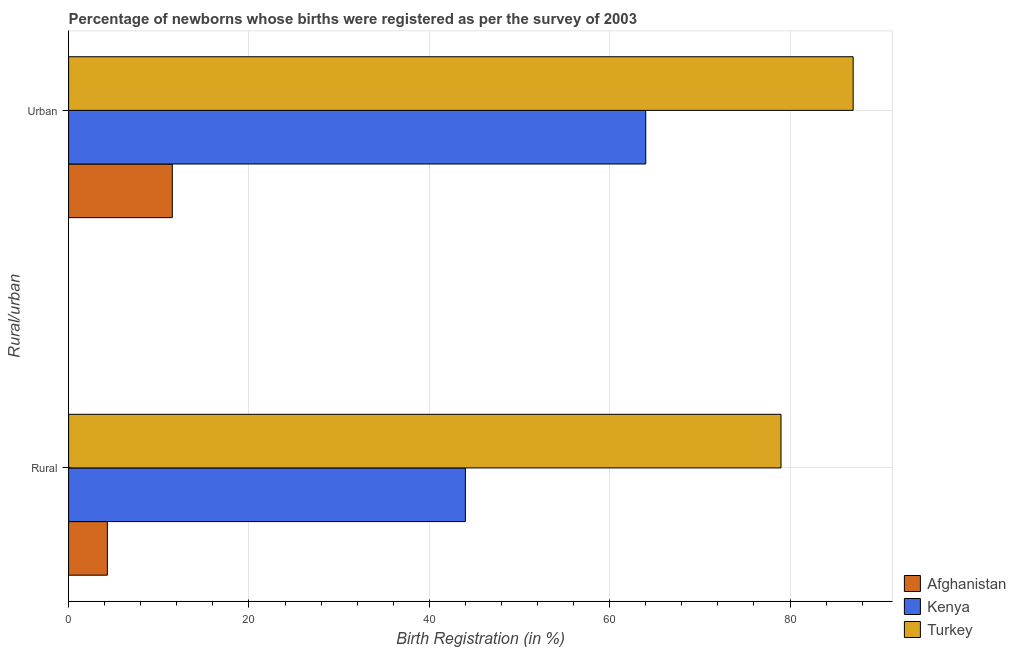Are the number of bars per tick equal to the number of legend labels?
Offer a terse response. Yes. Are the number of bars on each tick of the Y-axis equal?
Ensure brevity in your answer.  Yes. How many bars are there on the 1st tick from the top?
Your answer should be compact. 3. How many bars are there on the 2nd tick from the bottom?
Provide a succinct answer. 3. What is the label of the 1st group of bars from the top?
Your answer should be compact. Urban. What is the rural birth registration in Kenya?
Your answer should be compact. 44. Across all countries, what is the maximum rural birth registration?
Provide a succinct answer. 79. Across all countries, what is the minimum rural birth registration?
Provide a succinct answer. 4.3. In which country was the rural birth registration minimum?
Your answer should be very brief. Afghanistan. What is the total rural birth registration in the graph?
Your answer should be very brief. 127.3. What is the difference between the urban birth registration in Afghanistan and that in Turkey?
Make the answer very short. -75.5. What is the difference between the urban birth registration in Turkey and the rural birth registration in Afghanistan?
Give a very brief answer. 82.7. What is the average rural birth registration per country?
Give a very brief answer. 42.43. What is the difference between the urban birth registration and rural birth registration in Afghanistan?
Provide a short and direct response. 7.2. In how many countries, is the rural birth registration greater than 8 %?
Offer a terse response. 2. What is the ratio of the urban birth registration in Kenya to that in Afghanistan?
Provide a succinct answer. 5.57. What does the 2nd bar from the top in Urban represents?
Make the answer very short. Kenya. What does the 2nd bar from the bottom in Rural represents?
Provide a succinct answer. Kenya. Are the values on the major ticks of X-axis written in scientific E-notation?
Offer a terse response. No. How are the legend labels stacked?
Provide a succinct answer. Vertical. What is the title of the graph?
Provide a succinct answer. Percentage of newborns whose births were registered as per the survey of 2003. Does "Uruguay" appear as one of the legend labels in the graph?
Your answer should be very brief. No. What is the label or title of the X-axis?
Provide a succinct answer. Birth Registration (in %). What is the label or title of the Y-axis?
Offer a terse response. Rural/urban. What is the Birth Registration (in %) in Afghanistan in Rural?
Keep it short and to the point. 4.3. What is the Birth Registration (in %) in Kenya in Rural?
Offer a very short reply. 44. What is the Birth Registration (in %) of Turkey in Rural?
Keep it short and to the point. 79. Across all Rural/urban, what is the maximum Birth Registration (in %) of Afghanistan?
Give a very brief answer. 11.5. Across all Rural/urban, what is the maximum Birth Registration (in %) in Kenya?
Ensure brevity in your answer.  64. Across all Rural/urban, what is the maximum Birth Registration (in %) of Turkey?
Give a very brief answer. 87. Across all Rural/urban, what is the minimum Birth Registration (in %) of Kenya?
Provide a succinct answer. 44. Across all Rural/urban, what is the minimum Birth Registration (in %) in Turkey?
Offer a terse response. 79. What is the total Birth Registration (in %) in Afghanistan in the graph?
Provide a short and direct response. 15.8. What is the total Birth Registration (in %) of Kenya in the graph?
Offer a very short reply. 108. What is the total Birth Registration (in %) in Turkey in the graph?
Provide a short and direct response. 166. What is the difference between the Birth Registration (in %) of Afghanistan in Rural and that in Urban?
Your response must be concise. -7.2. What is the difference between the Birth Registration (in %) in Afghanistan in Rural and the Birth Registration (in %) in Kenya in Urban?
Ensure brevity in your answer.  -59.7. What is the difference between the Birth Registration (in %) in Afghanistan in Rural and the Birth Registration (in %) in Turkey in Urban?
Keep it short and to the point. -82.7. What is the difference between the Birth Registration (in %) in Kenya in Rural and the Birth Registration (in %) in Turkey in Urban?
Offer a very short reply. -43. What is the average Birth Registration (in %) in Kenya per Rural/urban?
Your response must be concise. 54. What is the average Birth Registration (in %) in Turkey per Rural/urban?
Your response must be concise. 83. What is the difference between the Birth Registration (in %) in Afghanistan and Birth Registration (in %) in Kenya in Rural?
Your answer should be compact. -39.7. What is the difference between the Birth Registration (in %) of Afghanistan and Birth Registration (in %) of Turkey in Rural?
Provide a short and direct response. -74.7. What is the difference between the Birth Registration (in %) in Kenya and Birth Registration (in %) in Turkey in Rural?
Keep it short and to the point. -35. What is the difference between the Birth Registration (in %) of Afghanistan and Birth Registration (in %) of Kenya in Urban?
Provide a short and direct response. -52.5. What is the difference between the Birth Registration (in %) of Afghanistan and Birth Registration (in %) of Turkey in Urban?
Provide a succinct answer. -75.5. What is the ratio of the Birth Registration (in %) in Afghanistan in Rural to that in Urban?
Your answer should be compact. 0.37. What is the ratio of the Birth Registration (in %) in Kenya in Rural to that in Urban?
Provide a succinct answer. 0.69. What is the ratio of the Birth Registration (in %) of Turkey in Rural to that in Urban?
Your answer should be very brief. 0.91. What is the difference between the highest and the second highest Birth Registration (in %) in Kenya?
Make the answer very short. 20. What is the difference between the highest and the lowest Birth Registration (in %) of Kenya?
Offer a terse response. 20. What is the difference between the highest and the lowest Birth Registration (in %) in Turkey?
Your answer should be very brief. 8. 